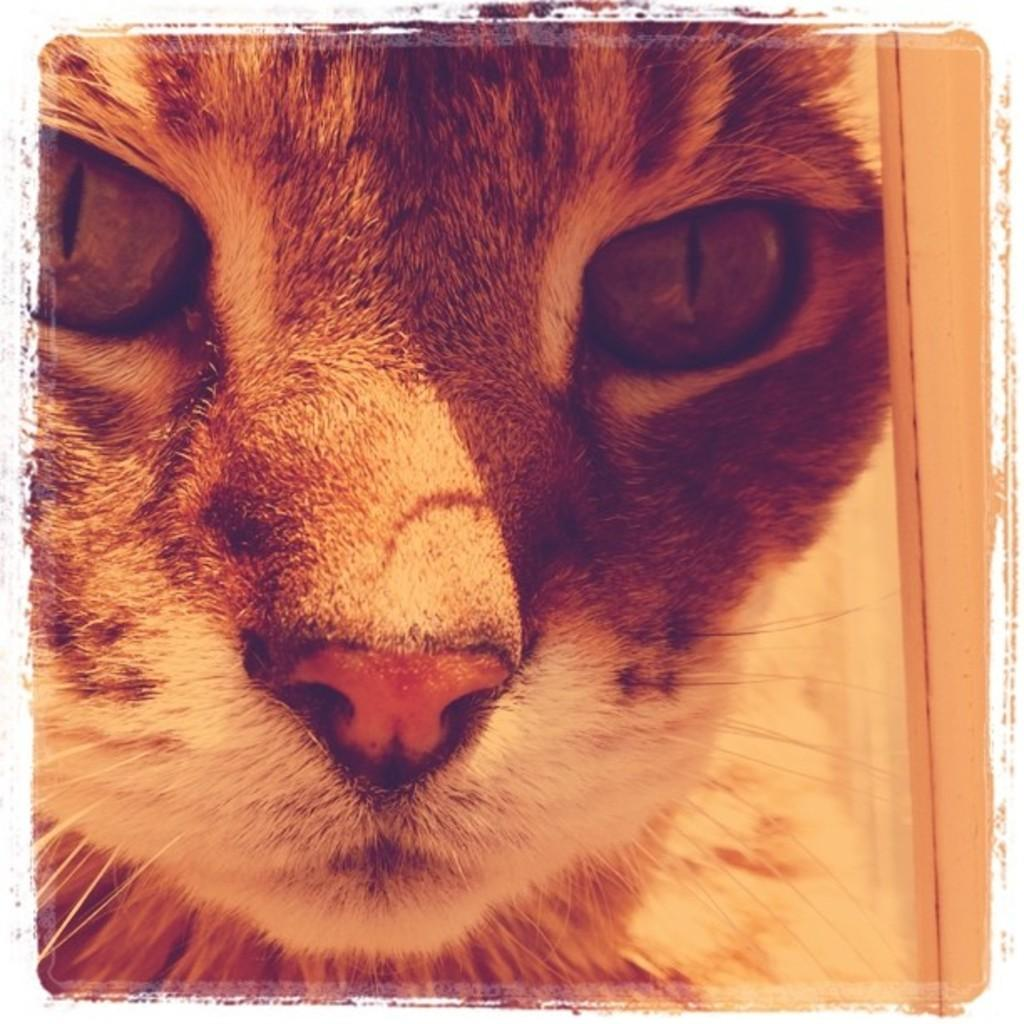What type of animal is present in the image? There is a cat in the image. Can you hear the cat whistling in the image? There is no indication of sound in the image, and cats do not have the ability to whistle. 